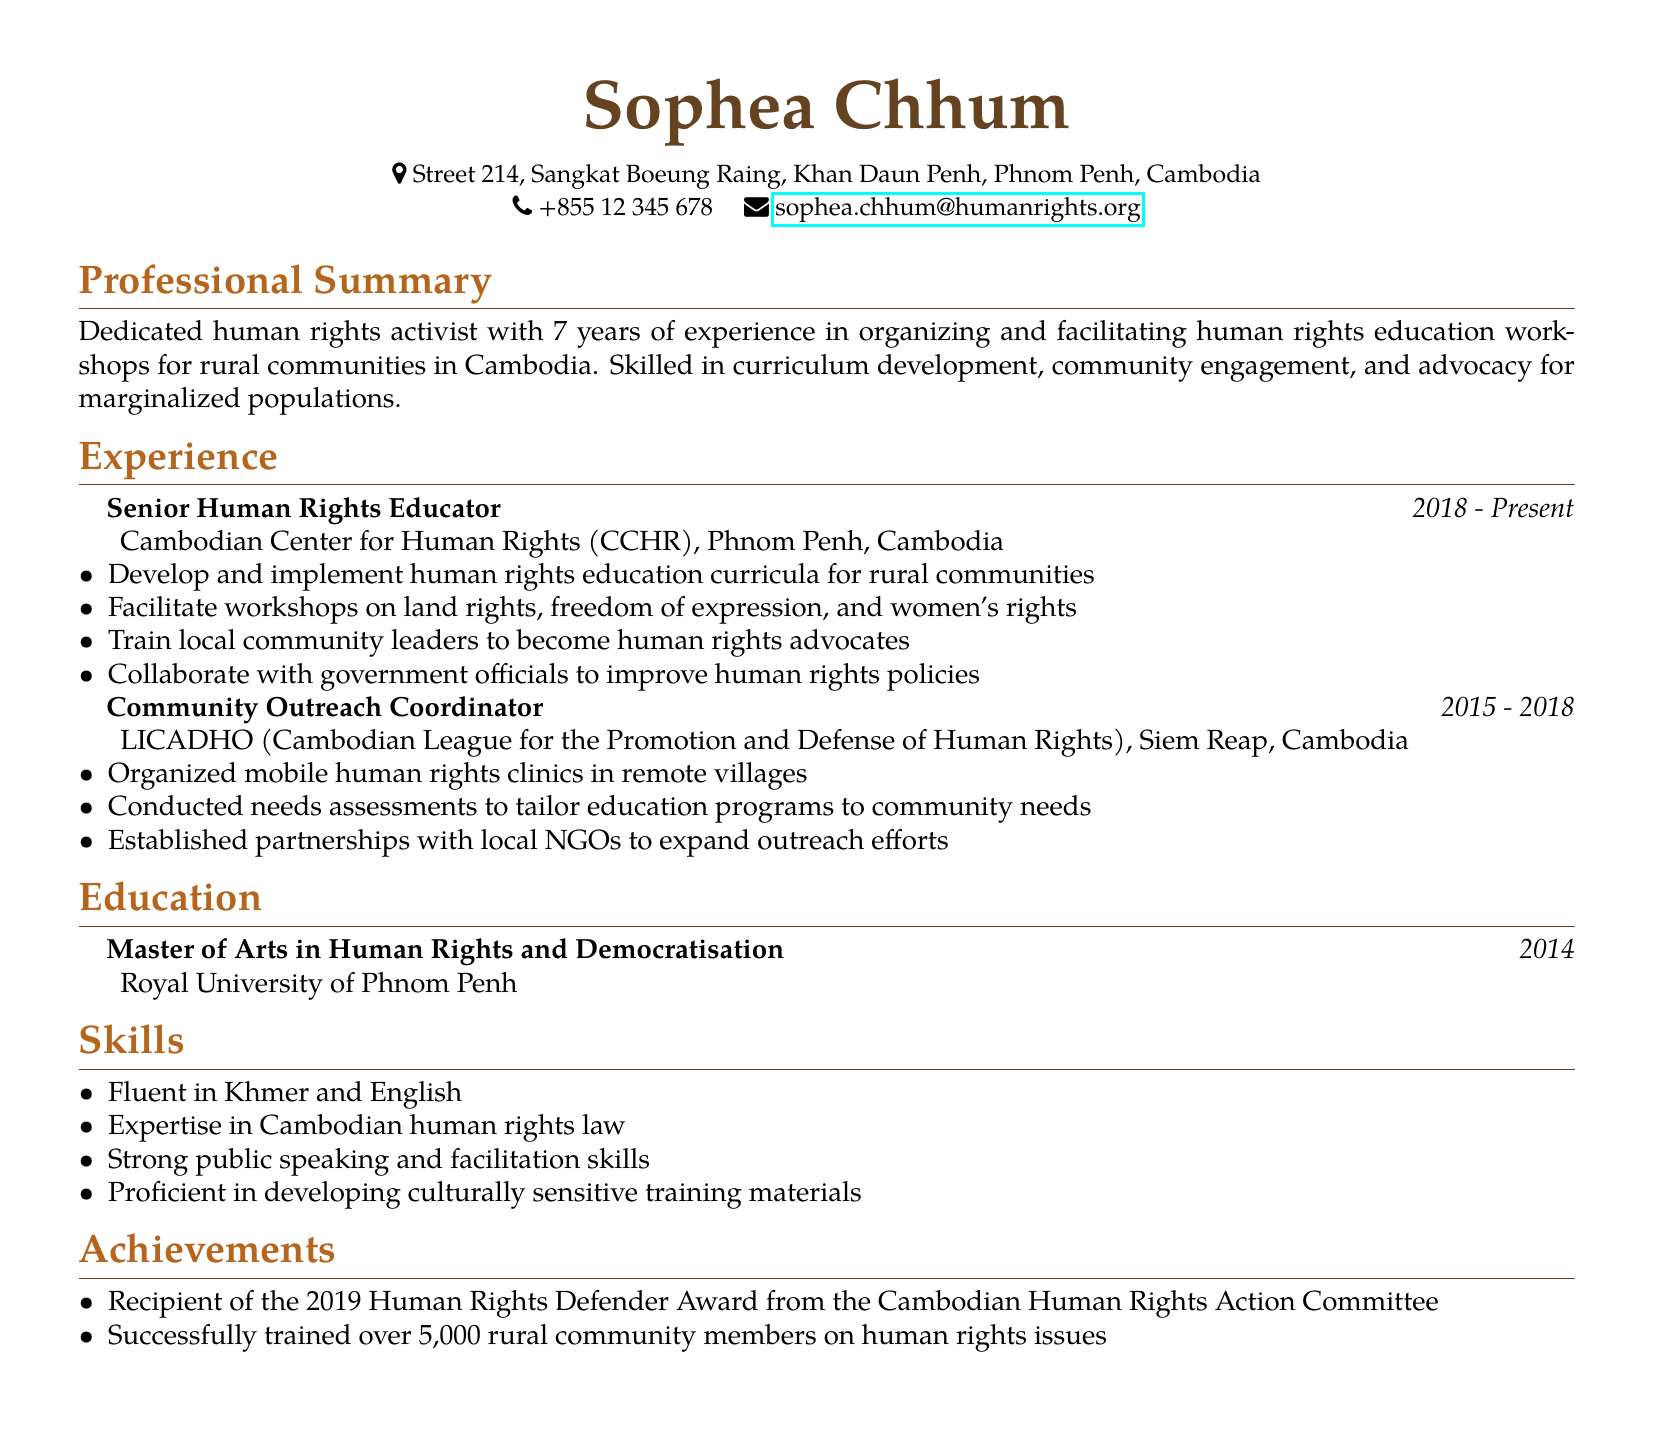What is the name of the individual? The document lists the individual's name as Sophea Chhum.
Answer: Sophea Chhum What is the highest degree attained by the individual? The document states that the individual has a Master of Arts in Human Rights and Democratisation.
Answer: Master of Arts in Human Rights and Democratisation Which organization does the individual currently work for? The document indicates that the individual is currently a Senior Human Rights Educator at the Cambodian Center for Human Rights (CCHR).
Answer: Cambodian Center for Human Rights (CCHR) How many years of experience does the individual have in human rights education? The professional summary mentions that the individual has 7 years of experience in this field.
Answer: 7 years What is one of the responsibilities of the Senior Human Rights Educator? The document lists developing and implementing human rights education curricula for rural communities as one responsibility.
Answer: Develop and implement human rights education curricula for rural communities How many rural community members has the individual successfully trained? The document states that the individual has trained over 5,000 rural community members on human rights issues.
Answer: Over 5,000 What languages is the individual fluent in? The skills section mentions fluency in Khmer and English.
Answer: Khmer and English What was the award received by the individual in 2019? The achievements section notes that the individual received the Human Rights Defender Award from the Cambodian Human Rights Action Committee.
Answer: Human Rights Defender Award Which location is associated with the Community Outreach Coordinator role? The experience section states that the individual worked as a Community Outreach Coordinator in Siem Reap, Cambodia.
Answer: Siem Reap, Cambodia 